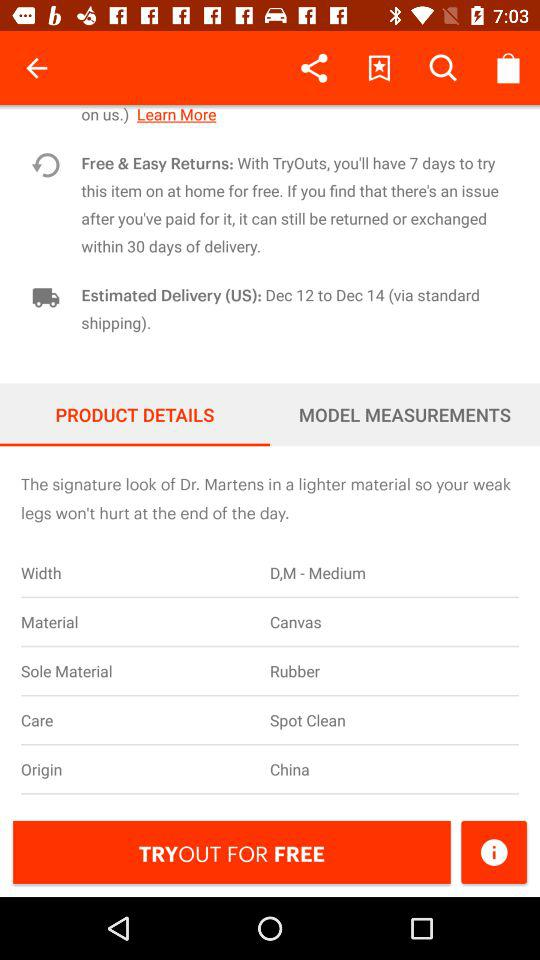What is the delivery time for this item?
Answer the question using a single word or phrase. Dec 12 to Dec 14 